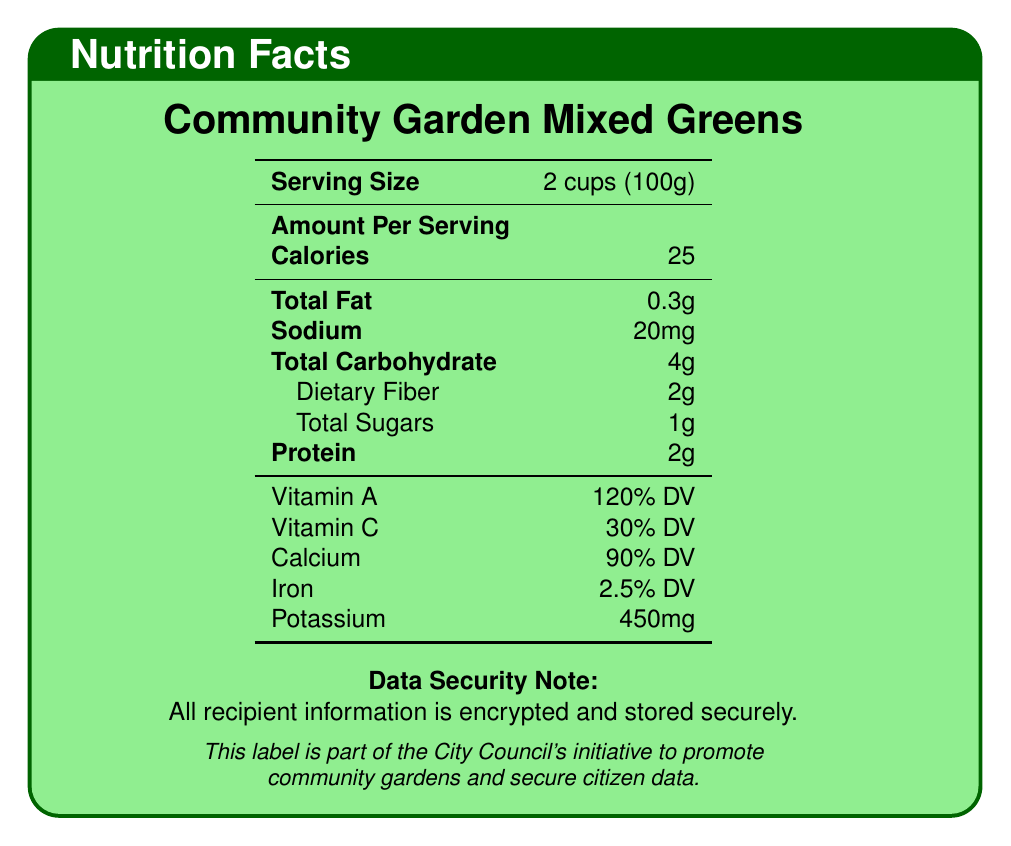What is the serving size of Community Garden Mixed Greens? The serving size is clearly mentioned in the document under the item 'Community Garden Mixed Greens'.
Answer: 2 cups (100g) How much protein is in one serving of Community Garden Mixed Greens? The document lists the protein content for Community Garden Mixed Greens as 2g per serving.
Answer: 2g What is the calcium content percentage of Community Garden Mixed Greens? The document specifies that the calcium content is 90% of the daily value (DV) for Community Garden Mixed Greens.
Answer: 90% DV What are the total carbohydrates in Locally Grown Bell Peppers? For Locally Grown Bell Peppers, the document lists the total carbohydrate content as 6g.
Answer: 6g How much iron do Organic Cherry Tomatoes contain? The document states that Organic Cherry Tomatoes contain 0.5% of the daily value for iron.
Answer: 0.5% DV Which item has the highest vitamin A percentage? A. Community Garden Mixed Greens B. Organic Cherry Tomatoes C. Locally Grown Bell Peppers The document lists vitamin A percentages as follows: Community Garden Mixed Greens (120% DV), Organic Cherry Tomatoes (20% DV), and Locally Grown Bell Peppers (7% DV). Therefore, the highest is Community Garden Mixed Greens.
Answer: A. Community Garden Mixed Greens Which item has the lowest sodium content? A. Community Garden Mixed Greens B. Organic Cherry Tomatoes C. Locally Grown Bell Peppers The sodium content in the document is as follows: Community Garden Mixed Greens (20mg), Organic Cherry Tomatoes (9mg), and Locally Grown Bell Peppers (4mg). Hence, Locally Grown Bell Peppers have the lowest sodium content.
Answer: C. Locally Grown Bell Peppers Do Community Garden Mixed Greens have more fiber than Locally Grown Bell Peppers? Community Garden Mixed Greens have 2g of dietary fiber while Locally Grown Bell Peppers also contain 2g. Hence, they have the same fiber content.
Answer: Yes Summarize the document, including the main points regarding nutrition and data security. Based on the provided document, it includes structured nutrition details for various community garden produce and outlines key data security practices to protect sensitive citizen information during food distribution.
Answer: The document provides detailed nutrition facts for three items distributed to food banks: Community Garden Mixed Greens, Organic Cherry Tomatoes, and Locally Grown Bell Peppers. It includes serving size, calorie count, and nutrient details such as fat, sodium, carbohydrate, fiber, sugar, protein, vitamins (A and C), calcium, iron, and potassium. Additionally, the document emphasizes data security measures such as encryption, secure storage, two-factor authentication, regular audits, volunteer training, and using anonymized data when reporting statistics. How does the document ensure the security of citizen data? The document details several measures to ensure the security of citizen data, including encryption of records, secure server storage, two-factor authentication for database access, regular security audits, volunteer training on data handling, and using anonymized data for reporting.
Answer: Encryption and secure storage, two-factor authentication, regular security audits, training volunteers, and anonymizing data for reporting. What is the potassium content in Community Garden Mixed Greens? The document states that Community Garden Mixed Greens contain 450mg of potassium per serving.
Answer: 450mg What is the main idea behind the data security note mentioned in the document? The data security note aims to reassure that all recipient information is encrypted and stored on secure servers, ensuring the protection of sensitive data.
Answer: To inform that all recipient information is encrypted and stored securely. Does the document provide information about the total amounts of food distributed to food banks? The document focuses on the nutritional profile of certain produce and data security measures, without mentioning the total amounts of food distributed.
Answer: Cannot be determined 